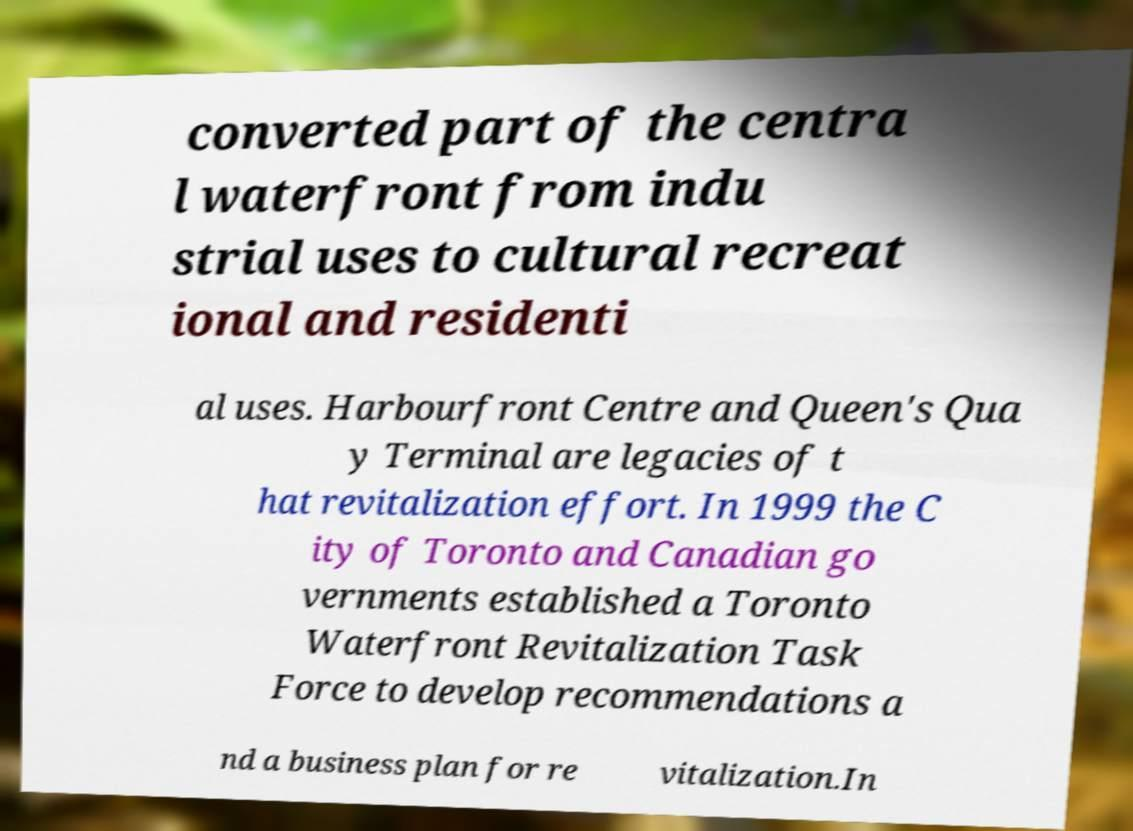Could you assist in decoding the text presented in this image and type it out clearly? converted part of the centra l waterfront from indu strial uses to cultural recreat ional and residenti al uses. Harbourfront Centre and Queen's Qua y Terminal are legacies of t hat revitalization effort. In 1999 the C ity of Toronto and Canadian go vernments established a Toronto Waterfront Revitalization Task Force to develop recommendations a nd a business plan for re vitalization.In 